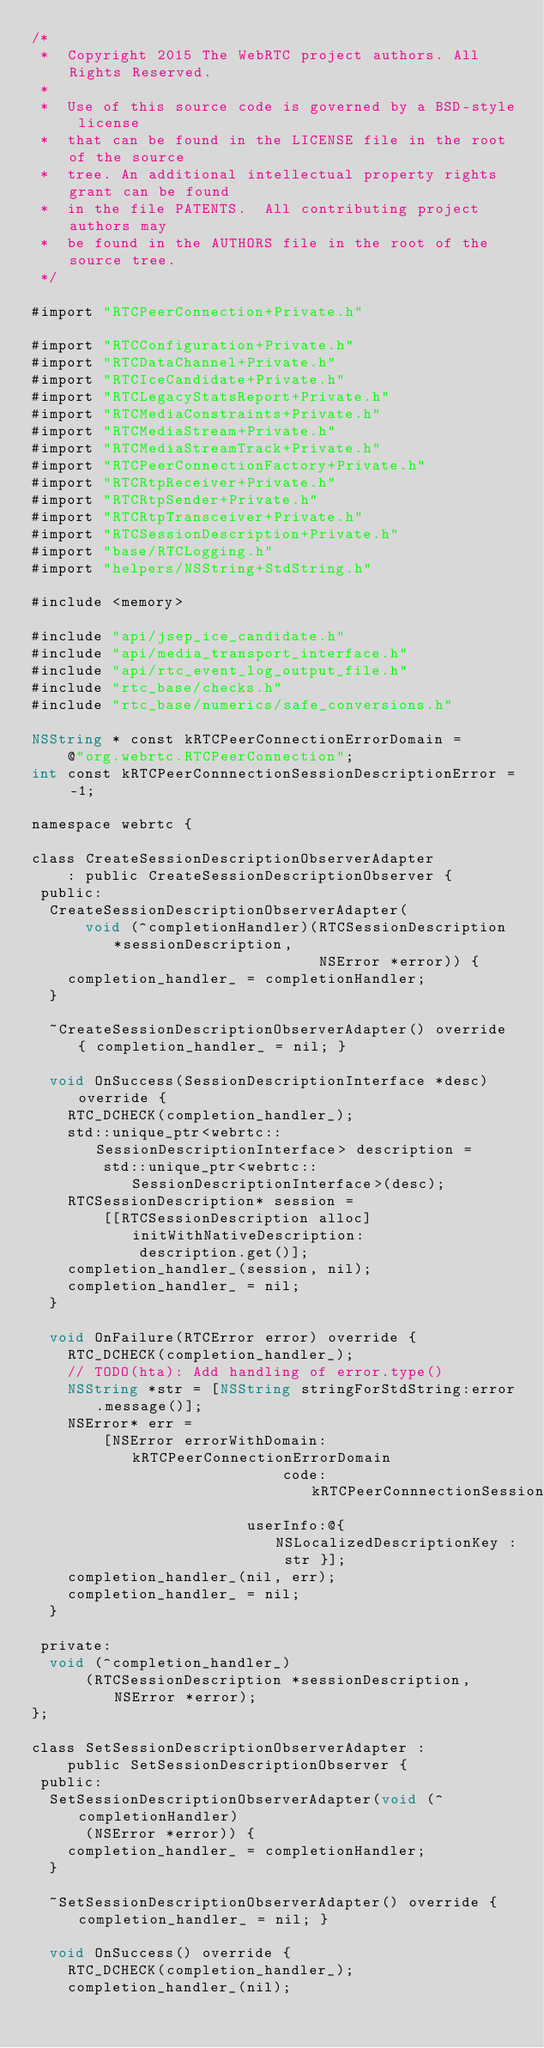Convert code to text. <code><loc_0><loc_0><loc_500><loc_500><_ObjectiveC_>/*
 *  Copyright 2015 The WebRTC project authors. All Rights Reserved.
 *
 *  Use of this source code is governed by a BSD-style license
 *  that can be found in the LICENSE file in the root of the source
 *  tree. An additional intellectual property rights grant can be found
 *  in the file PATENTS.  All contributing project authors may
 *  be found in the AUTHORS file in the root of the source tree.
 */

#import "RTCPeerConnection+Private.h"

#import "RTCConfiguration+Private.h"
#import "RTCDataChannel+Private.h"
#import "RTCIceCandidate+Private.h"
#import "RTCLegacyStatsReport+Private.h"
#import "RTCMediaConstraints+Private.h"
#import "RTCMediaStream+Private.h"
#import "RTCMediaStreamTrack+Private.h"
#import "RTCPeerConnectionFactory+Private.h"
#import "RTCRtpReceiver+Private.h"
#import "RTCRtpSender+Private.h"
#import "RTCRtpTransceiver+Private.h"
#import "RTCSessionDescription+Private.h"
#import "base/RTCLogging.h"
#import "helpers/NSString+StdString.h"

#include <memory>

#include "api/jsep_ice_candidate.h"
#include "api/media_transport_interface.h"
#include "api/rtc_event_log_output_file.h"
#include "rtc_base/checks.h"
#include "rtc_base/numerics/safe_conversions.h"

NSString * const kRTCPeerConnectionErrorDomain =
    @"org.webrtc.RTCPeerConnection";
int const kRTCPeerConnnectionSessionDescriptionError = -1;

namespace webrtc {

class CreateSessionDescriptionObserverAdapter
    : public CreateSessionDescriptionObserver {
 public:
  CreateSessionDescriptionObserverAdapter(
      void (^completionHandler)(RTCSessionDescription *sessionDescription,
                                NSError *error)) {
    completion_handler_ = completionHandler;
  }

  ~CreateSessionDescriptionObserverAdapter() override { completion_handler_ = nil; }

  void OnSuccess(SessionDescriptionInterface *desc) override {
    RTC_DCHECK(completion_handler_);
    std::unique_ptr<webrtc::SessionDescriptionInterface> description =
        std::unique_ptr<webrtc::SessionDescriptionInterface>(desc);
    RTCSessionDescription* session =
        [[RTCSessionDescription alloc] initWithNativeDescription:
            description.get()];
    completion_handler_(session, nil);
    completion_handler_ = nil;
  }

  void OnFailure(RTCError error) override {
    RTC_DCHECK(completion_handler_);
    // TODO(hta): Add handling of error.type()
    NSString *str = [NSString stringForStdString:error.message()];
    NSError* err =
        [NSError errorWithDomain:kRTCPeerConnectionErrorDomain
                            code:kRTCPeerConnnectionSessionDescriptionError
                        userInfo:@{ NSLocalizedDescriptionKey : str }];
    completion_handler_(nil, err);
    completion_handler_ = nil;
  }

 private:
  void (^completion_handler_)
      (RTCSessionDescription *sessionDescription, NSError *error);
};

class SetSessionDescriptionObserverAdapter :
    public SetSessionDescriptionObserver {
 public:
  SetSessionDescriptionObserverAdapter(void (^completionHandler)
      (NSError *error)) {
    completion_handler_ = completionHandler;
  }

  ~SetSessionDescriptionObserverAdapter() override { completion_handler_ = nil; }

  void OnSuccess() override {
    RTC_DCHECK(completion_handler_);
    completion_handler_(nil);</code> 